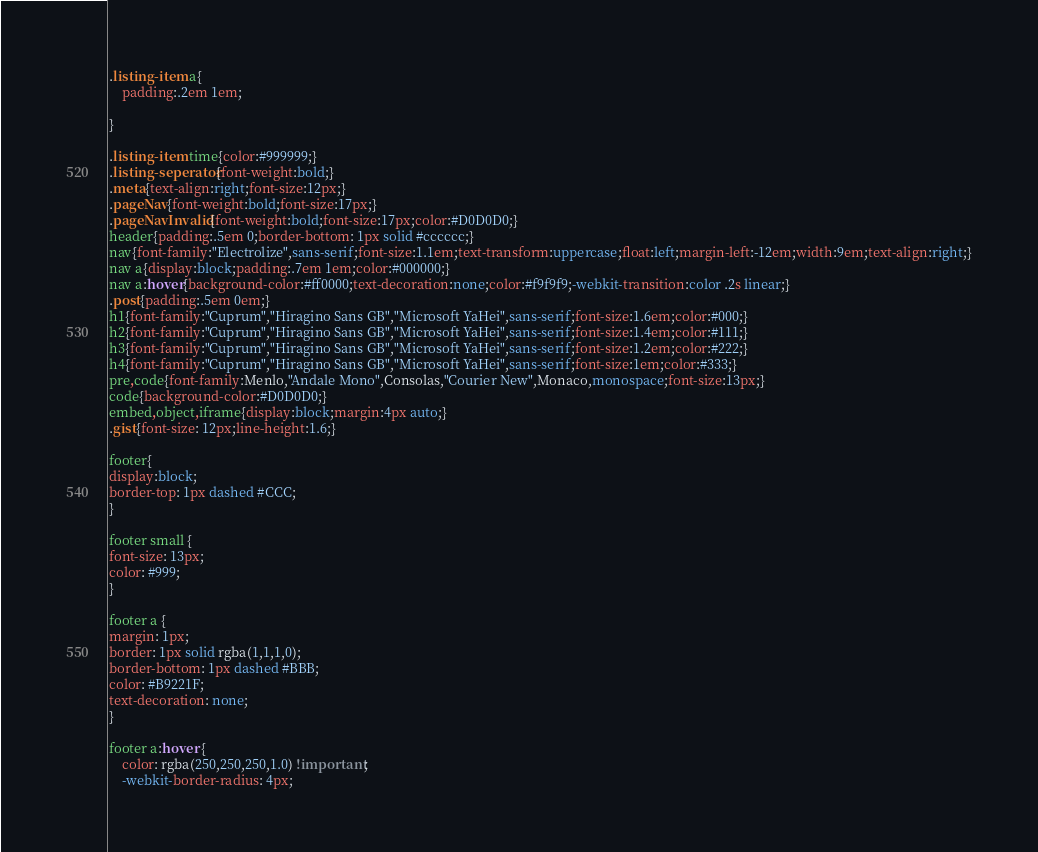Convert code to text. <code><loc_0><loc_0><loc_500><loc_500><_CSS_>.listing-item a{
	padding:.2em 1em;

}

.listing-item time{color:#999999;}
.listing-seperator{font-weight:bold;}
.meta{text-align:right;font-size:12px;}
.pageNav{font-weight:bold;font-size:17px;}
.pageNavInvalid{font-weight:bold;font-size:17px;color:#D0D0D0;}
header{padding:.5em 0;border-bottom: 1px solid #cccccc;}
nav{font-family:"Electrolize",sans-serif;font-size:1.1em;text-transform:uppercase;float:left;margin-left:-12em;width:9em;text-align:right;}
nav a{display:block;padding:.7em 1em;color:#000000;}
nav a:hover{background-color:#ff0000;text-decoration:none;color:#f9f9f9;-webkit-transition:color .2s linear;}
.post{padding:.5em 0em;}
h1{font-family:"Cuprum","Hiragino Sans GB","Microsoft YaHei",sans-serif;font-size:1.6em;color:#000;}
h2{font-family:"Cuprum","Hiragino Sans GB","Microsoft YaHei",sans-serif;font-size:1.4em;color:#111;}
h3{font-family:"Cuprum","Hiragino Sans GB","Microsoft YaHei",sans-serif;font-size:1.2em;color:#222;}
h4{font-family:"Cuprum","Hiragino Sans GB","Microsoft YaHei",sans-serif;font-size:1em;color:#333;}
pre,code{font-family:Menlo,"Andale Mono",Consolas,"Courier New",Monaco,monospace;font-size:13px;}
code{background-color:#D0D0D0;}
embed,object,iframe{display:block;margin:4px auto;}
.gist{font-size: 12px;line-height:1.6;}

footer{
display:block;
border-top: 1px dashed #CCC;
}

footer small {
font-size: 13px;
color: #999;
}

footer a {
margin: 1px;
border: 1px solid rgba(1,1,1,0);
border-bottom: 1px dashed #BBB;
color: #B9221F;
text-decoration: none;
}

footer a:hover {
	color: rgba(250,250,250,1.0) !important; 
    -webkit-border-radius: 4px;</code> 